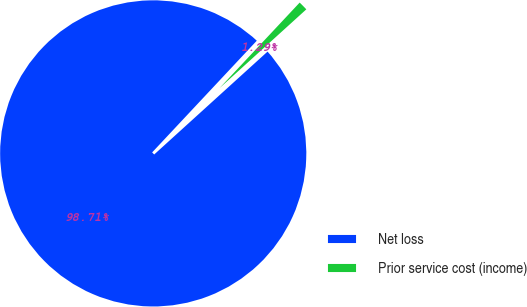Convert chart. <chart><loc_0><loc_0><loc_500><loc_500><pie_chart><fcel>Net loss<fcel>Prior service cost (income)<nl><fcel>98.71%<fcel>1.29%<nl></chart> 